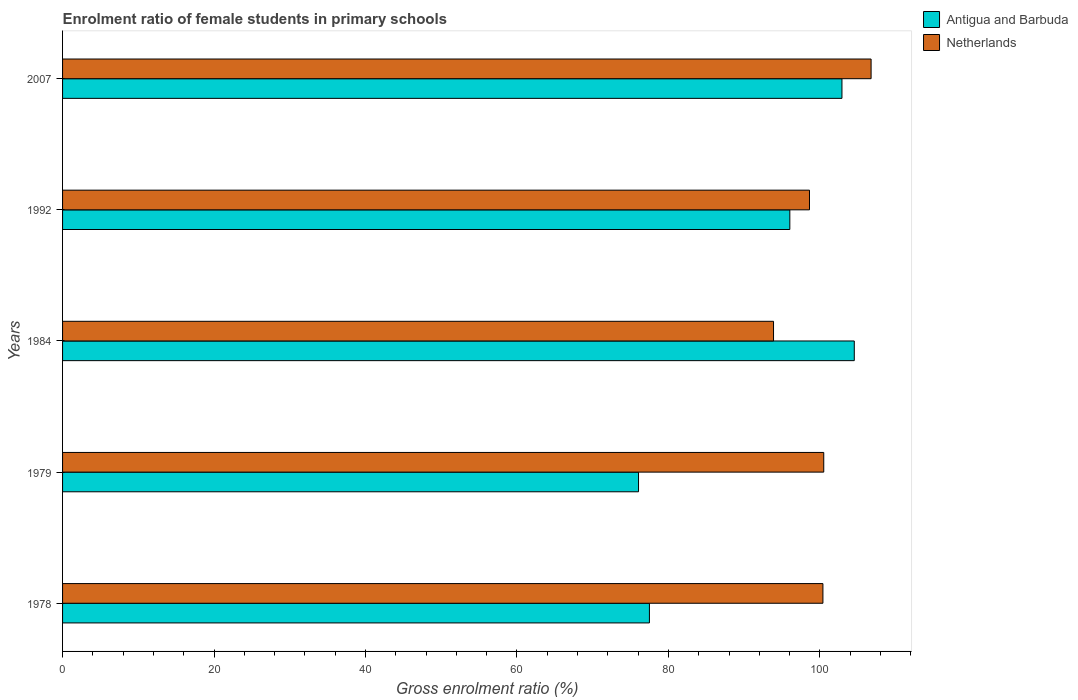How many groups of bars are there?
Make the answer very short. 5. Are the number of bars per tick equal to the number of legend labels?
Your answer should be very brief. Yes. Are the number of bars on each tick of the Y-axis equal?
Your answer should be very brief. Yes. How many bars are there on the 5th tick from the bottom?
Make the answer very short. 2. What is the label of the 4th group of bars from the top?
Provide a succinct answer. 1979. What is the enrolment ratio of female students in primary schools in Antigua and Barbuda in 2007?
Offer a very short reply. 102.91. Across all years, what is the maximum enrolment ratio of female students in primary schools in Netherlands?
Make the answer very short. 106.76. Across all years, what is the minimum enrolment ratio of female students in primary schools in Netherlands?
Make the answer very short. 93.87. In which year was the enrolment ratio of female students in primary schools in Netherlands maximum?
Offer a terse response. 2007. In which year was the enrolment ratio of female students in primary schools in Netherlands minimum?
Offer a terse response. 1984. What is the total enrolment ratio of female students in primary schools in Netherlands in the graph?
Offer a terse response. 500.16. What is the difference between the enrolment ratio of female students in primary schools in Netherlands in 1979 and that in 1992?
Your answer should be very brief. 1.88. What is the difference between the enrolment ratio of female students in primary schools in Netherlands in 1979 and the enrolment ratio of female students in primary schools in Antigua and Barbuda in 1978?
Offer a terse response. 23.02. What is the average enrolment ratio of female students in primary schools in Antigua and Barbuda per year?
Offer a terse response. 91.4. In the year 1979, what is the difference between the enrolment ratio of female students in primary schools in Antigua and Barbuda and enrolment ratio of female students in primary schools in Netherlands?
Give a very brief answer. -24.46. In how many years, is the enrolment ratio of female students in primary schools in Antigua and Barbuda greater than 32 %?
Keep it short and to the point. 5. What is the ratio of the enrolment ratio of female students in primary schools in Antigua and Barbuda in 1978 to that in 1992?
Make the answer very short. 0.81. Is the difference between the enrolment ratio of female students in primary schools in Antigua and Barbuda in 1978 and 1984 greater than the difference between the enrolment ratio of female students in primary schools in Netherlands in 1978 and 1984?
Provide a short and direct response. No. What is the difference between the highest and the second highest enrolment ratio of female students in primary schools in Netherlands?
Your answer should be very brief. 6.25. What is the difference between the highest and the lowest enrolment ratio of female students in primary schools in Netherlands?
Your response must be concise. 12.88. Is the sum of the enrolment ratio of female students in primary schools in Netherlands in 1979 and 1984 greater than the maximum enrolment ratio of female students in primary schools in Antigua and Barbuda across all years?
Make the answer very short. Yes. What does the 2nd bar from the top in 2007 represents?
Your answer should be compact. Antigua and Barbuda. How many bars are there?
Provide a short and direct response. 10. How many years are there in the graph?
Give a very brief answer. 5. Does the graph contain grids?
Offer a very short reply. No. What is the title of the graph?
Your response must be concise. Enrolment ratio of female students in primary schools. Does "Philippines" appear as one of the legend labels in the graph?
Ensure brevity in your answer.  No. What is the label or title of the X-axis?
Give a very brief answer. Gross enrolment ratio (%). What is the label or title of the Y-axis?
Your answer should be compact. Years. What is the Gross enrolment ratio (%) of Antigua and Barbuda in 1978?
Give a very brief answer. 77.49. What is the Gross enrolment ratio (%) in Netherlands in 1978?
Give a very brief answer. 100.4. What is the Gross enrolment ratio (%) of Antigua and Barbuda in 1979?
Give a very brief answer. 76.05. What is the Gross enrolment ratio (%) of Netherlands in 1979?
Your answer should be very brief. 100.51. What is the Gross enrolment ratio (%) of Antigua and Barbuda in 1984?
Keep it short and to the point. 104.54. What is the Gross enrolment ratio (%) in Netherlands in 1984?
Your answer should be compact. 93.87. What is the Gross enrolment ratio (%) in Antigua and Barbuda in 1992?
Provide a succinct answer. 96.03. What is the Gross enrolment ratio (%) of Netherlands in 1992?
Your answer should be very brief. 98.62. What is the Gross enrolment ratio (%) in Antigua and Barbuda in 2007?
Your answer should be very brief. 102.91. What is the Gross enrolment ratio (%) of Netherlands in 2007?
Give a very brief answer. 106.76. Across all years, what is the maximum Gross enrolment ratio (%) in Antigua and Barbuda?
Give a very brief answer. 104.54. Across all years, what is the maximum Gross enrolment ratio (%) in Netherlands?
Offer a very short reply. 106.76. Across all years, what is the minimum Gross enrolment ratio (%) in Antigua and Barbuda?
Keep it short and to the point. 76.05. Across all years, what is the minimum Gross enrolment ratio (%) of Netherlands?
Keep it short and to the point. 93.87. What is the total Gross enrolment ratio (%) in Antigua and Barbuda in the graph?
Provide a succinct answer. 457.01. What is the total Gross enrolment ratio (%) in Netherlands in the graph?
Give a very brief answer. 500.16. What is the difference between the Gross enrolment ratio (%) of Antigua and Barbuda in 1978 and that in 1979?
Your answer should be very brief. 1.44. What is the difference between the Gross enrolment ratio (%) in Netherlands in 1978 and that in 1979?
Give a very brief answer. -0.11. What is the difference between the Gross enrolment ratio (%) of Antigua and Barbuda in 1978 and that in 1984?
Your answer should be compact. -27.05. What is the difference between the Gross enrolment ratio (%) in Netherlands in 1978 and that in 1984?
Provide a succinct answer. 6.52. What is the difference between the Gross enrolment ratio (%) in Antigua and Barbuda in 1978 and that in 1992?
Offer a very short reply. -18.54. What is the difference between the Gross enrolment ratio (%) in Netherlands in 1978 and that in 1992?
Provide a short and direct response. 1.77. What is the difference between the Gross enrolment ratio (%) in Antigua and Barbuda in 1978 and that in 2007?
Make the answer very short. -25.42. What is the difference between the Gross enrolment ratio (%) in Netherlands in 1978 and that in 2007?
Provide a succinct answer. -6.36. What is the difference between the Gross enrolment ratio (%) of Antigua and Barbuda in 1979 and that in 1984?
Provide a short and direct response. -28.49. What is the difference between the Gross enrolment ratio (%) in Netherlands in 1979 and that in 1984?
Provide a short and direct response. 6.63. What is the difference between the Gross enrolment ratio (%) of Antigua and Barbuda in 1979 and that in 1992?
Offer a very short reply. -19.98. What is the difference between the Gross enrolment ratio (%) in Netherlands in 1979 and that in 1992?
Make the answer very short. 1.88. What is the difference between the Gross enrolment ratio (%) in Antigua and Barbuda in 1979 and that in 2007?
Your response must be concise. -26.86. What is the difference between the Gross enrolment ratio (%) of Netherlands in 1979 and that in 2007?
Provide a short and direct response. -6.25. What is the difference between the Gross enrolment ratio (%) of Antigua and Barbuda in 1984 and that in 1992?
Provide a succinct answer. 8.51. What is the difference between the Gross enrolment ratio (%) in Netherlands in 1984 and that in 1992?
Your answer should be very brief. -4.75. What is the difference between the Gross enrolment ratio (%) in Antigua and Barbuda in 1984 and that in 2007?
Your answer should be very brief. 1.63. What is the difference between the Gross enrolment ratio (%) in Netherlands in 1984 and that in 2007?
Provide a short and direct response. -12.88. What is the difference between the Gross enrolment ratio (%) in Antigua and Barbuda in 1992 and that in 2007?
Offer a very short reply. -6.88. What is the difference between the Gross enrolment ratio (%) in Netherlands in 1992 and that in 2007?
Your response must be concise. -8.14. What is the difference between the Gross enrolment ratio (%) in Antigua and Barbuda in 1978 and the Gross enrolment ratio (%) in Netherlands in 1979?
Keep it short and to the point. -23.02. What is the difference between the Gross enrolment ratio (%) of Antigua and Barbuda in 1978 and the Gross enrolment ratio (%) of Netherlands in 1984?
Offer a very short reply. -16.39. What is the difference between the Gross enrolment ratio (%) of Antigua and Barbuda in 1978 and the Gross enrolment ratio (%) of Netherlands in 1992?
Keep it short and to the point. -21.13. What is the difference between the Gross enrolment ratio (%) in Antigua and Barbuda in 1978 and the Gross enrolment ratio (%) in Netherlands in 2007?
Keep it short and to the point. -29.27. What is the difference between the Gross enrolment ratio (%) in Antigua and Barbuda in 1979 and the Gross enrolment ratio (%) in Netherlands in 1984?
Your response must be concise. -17.82. What is the difference between the Gross enrolment ratio (%) in Antigua and Barbuda in 1979 and the Gross enrolment ratio (%) in Netherlands in 1992?
Your response must be concise. -22.57. What is the difference between the Gross enrolment ratio (%) in Antigua and Barbuda in 1979 and the Gross enrolment ratio (%) in Netherlands in 2007?
Provide a short and direct response. -30.71. What is the difference between the Gross enrolment ratio (%) in Antigua and Barbuda in 1984 and the Gross enrolment ratio (%) in Netherlands in 1992?
Offer a very short reply. 5.92. What is the difference between the Gross enrolment ratio (%) of Antigua and Barbuda in 1984 and the Gross enrolment ratio (%) of Netherlands in 2007?
Offer a terse response. -2.22. What is the difference between the Gross enrolment ratio (%) of Antigua and Barbuda in 1992 and the Gross enrolment ratio (%) of Netherlands in 2007?
Offer a very short reply. -10.73. What is the average Gross enrolment ratio (%) of Antigua and Barbuda per year?
Offer a terse response. 91.4. What is the average Gross enrolment ratio (%) of Netherlands per year?
Make the answer very short. 100.03. In the year 1978, what is the difference between the Gross enrolment ratio (%) in Antigua and Barbuda and Gross enrolment ratio (%) in Netherlands?
Your response must be concise. -22.91. In the year 1979, what is the difference between the Gross enrolment ratio (%) in Antigua and Barbuda and Gross enrolment ratio (%) in Netherlands?
Your answer should be compact. -24.46. In the year 1984, what is the difference between the Gross enrolment ratio (%) of Antigua and Barbuda and Gross enrolment ratio (%) of Netherlands?
Ensure brevity in your answer.  10.66. In the year 1992, what is the difference between the Gross enrolment ratio (%) in Antigua and Barbuda and Gross enrolment ratio (%) in Netherlands?
Make the answer very short. -2.59. In the year 2007, what is the difference between the Gross enrolment ratio (%) of Antigua and Barbuda and Gross enrolment ratio (%) of Netherlands?
Your answer should be very brief. -3.85. What is the ratio of the Gross enrolment ratio (%) of Antigua and Barbuda in 1978 to that in 1979?
Offer a very short reply. 1.02. What is the ratio of the Gross enrolment ratio (%) of Netherlands in 1978 to that in 1979?
Provide a short and direct response. 1. What is the ratio of the Gross enrolment ratio (%) of Antigua and Barbuda in 1978 to that in 1984?
Offer a terse response. 0.74. What is the ratio of the Gross enrolment ratio (%) in Netherlands in 1978 to that in 1984?
Offer a very short reply. 1.07. What is the ratio of the Gross enrolment ratio (%) in Antigua and Barbuda in 1978 to that in 1992?
Ensure brevity in your answer.  0.81. What is the ratio of the Gross enrolment ratio (%) of Netherlands in 1978 to that in 1992?
Ensure brevity in your answer.  1.02. What is the ratio of the Gross enrolment ratio (%) in Antigua and Barbuda in 1978 to that in 2007?
Ensure brevity in your answer.  0.75. What is the ratio of the Gross enrolment ratio (%) of Netherlands in 1978 to that in 2007?
Offer a very short reply. 0.94. What is the ratio of the Gross enrolment ratio (%) of Antigua and Barbuda in 1979 to that in 1984?
Ensure brevity in your answer.  0.73. What is the ratio of the Gross enrolment ratio (%) in Netherlands in 1979 to that in 1984?
Give a very brief answer. 1.07. What is the ratio of the Gross enrolment ratio (%) in Antigua and Barbuda in 1979 to that in 1992?
Your answer should be very brief. 0.79. What is the ratio of the Gross enrolment ratio (%) of Netherlands in 1979 to that in 1992?
Your answer should be very brief. 1.02. What is the ratio of the Gross enrolment ratio (%) of Antigua and Barbuda in 1979 to that in 2007?
Ensure brevity in your answer.  0.74. What is the ratio of the Gross enrolment ratio (%) of Netherlands in 1979 to that in 2007?
Provide a short and direct response. 0.94. What is the ratio of the Gross enrolment ratio (%) in Antigua and Barbuda in 1984 to that in 1992?
Your answer should be compact. 1.09. What is the ratio of the Gross enrolment ratio (%) in Netherlands in 1984 to that in 1992?
Make the answer very short. 0.95. What is the ratio of the Gross enrolment ratio (%) of Antigua and Barbuda in 1984 to that in 2007?
Offer a terse response. 1.02. What is the ratio of the Gross enrolment ratio (%) in Netherlands in 1984 to that in 2007?
Your response must be concise. 0.88. What is the ratio of the Gross enrolment ratio (%) in Antigua and Barbuda in 1992 to that in 2007?
Your response must be concise. 0.93. What is the ratio of the Gross enrolment ratio (%) in Netherlands in 1992 to that in 2007?
Provide a succinct answer. 0.92. What is the difference between the highest and the second highest Gross enrolment ratio (%) of Antigua and Barbuda?
Offer a very short reply. 1.63. What is the difference between the highest and the second highest Gross enrolment ratio (%) of Netherlands?
Your answer should be very brief. 6.25. What is the difference between the highest and the lowest Gross enrolment ratio (%) in Antigua and Barbuda?
Make the answer very short. 28.49. What is the difference between the highest and the lowest Gross enrolment ratio (%) of Netherlands?
Your answer should be very brief. 12.88. 